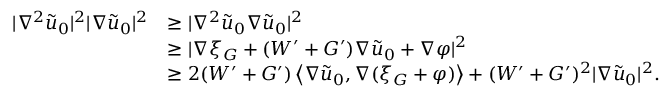<formula> <loc_0><loc_0><loc_500><loc_500>\begin{array} { r l } { | \nabla ^ { 2 } \tilde { u } _ { 0 } | ^ { 2 } | \nabla \tilde { u } _ { 0 } | ^ { 2 } } & { \geq | \nabla ^ { 2 } \tilde { u } _ { 0 } \nabla \tilde { u } _ { 0 } | ^ { 2 } } \\ & { \geq | \nabla \xi _ { G } + ( W ^ { \prime } + G ^ { \prime } ) \nabla \tilde { u } _ { 0 } + \nabla \varphi | ^ { 2 } } \\ & { \geq 2 ( W ^ { \prime } + G ^ { \prime } ) \left \langle \nabla \tilde { u } _ { 0 } , \nabla ( \xi _ { G } + \varphi ) \right \rangle + ( W ^ { \prime } + G ^ { \prime } ) ^ { 2 } | \nabla \tilde { u } _ { 0 } | ^ { 2 } . } \end{array}</formula> 